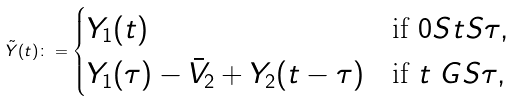Convert formula to latex. <formula><loc_0><loc_0><loc_500><loc_500>\tilde { Y } ( t ) \colon = \begin{cases} Y _ { 1 } ( t ) & \text {if } 0 \L S t \L S \tau , \\ Y _ { 1 } ( \tau ) - \bar { V } _ { 2 } + Y _ { 2 } ( t - \tau ) & \text {if } t \ G S \tau , \end{cases}</formula> 